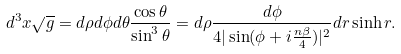<formula> <loc_0><loc_0><loc_500><loc_500>d ^ { 3 } x \sqrt { g } = d \rho d \phi d \theta \frac { \cos \theta } { \sin ^ { 3 } \theta } = d \rho \frac { d \phi } { 4 | \sin ( \phi + i \frac { n \beta } { 4 } ) | ^ { 2 } } d r \sinh r .</formula> 